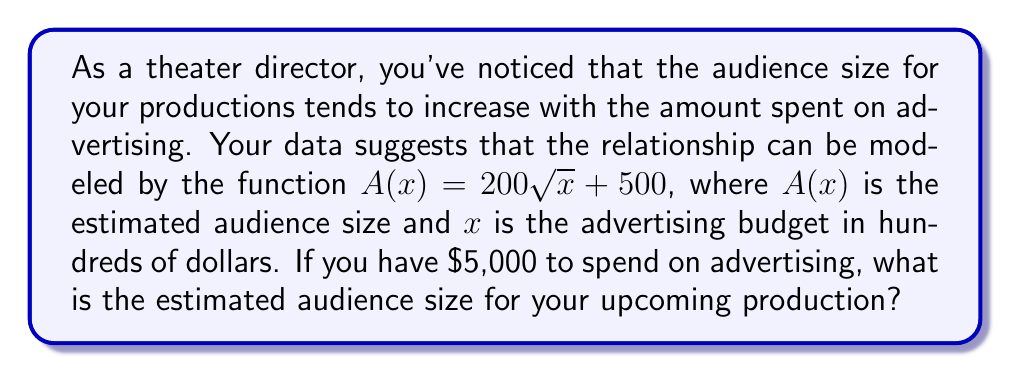Could you help me with this problem? Let's approach this step-by-step:

1) We're given the function $A(x) = 200\sqrt{x} + 500$, where:
   - $A(x)$ is the estimated audience size
   - $x$ is the advertising budget in hundreds of dollars

2) We need to find $A(x)$ when the advertising budget is $5,000.

3) First, we need to convert $5,000 to the correct units for $x$:
   $5,000 = 50$ hundreds of dollars

4) So, we need to calculate $A(50)$:

   $A(50) = 200\sqrt{50} + 500$

5) Let's solve this:
   - $\sqrt{50} = 5\sqrt{2} \approx 7.071$
   - $200 * 7.071 = 1,414.2$
   - $1,414.2 + 500 = 1,914.2$

6) Rounding to the nearest whole number (as we can't have a fractional audience member):
   $A(50) \approx 1,914$

Therefore, with an advertising budget of $5,000, the estimated audience size is approximately 1,914 people.
Answer: 1,914 people 